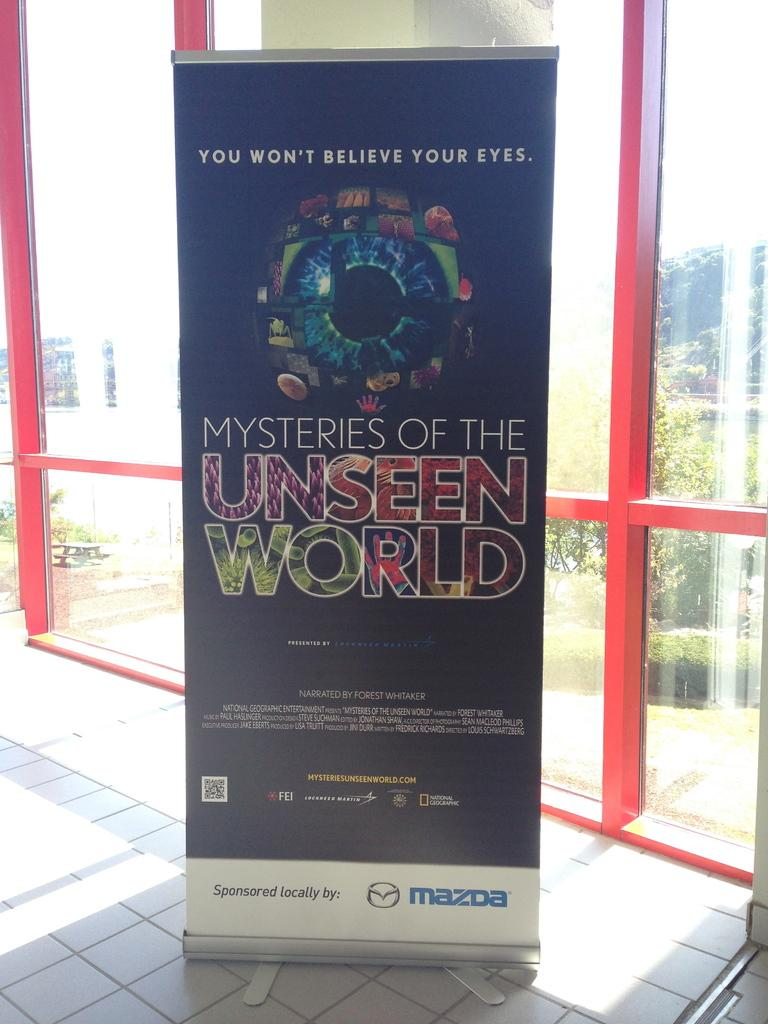<image>
Provide a brief description of the given image. A vertical sign says you won't believe your eyes. 